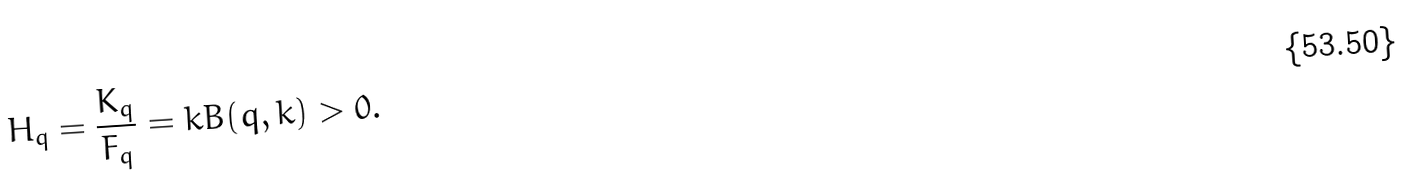Convert formula to latex. <formula><loc_0><loc_0><loc_500><loc_500>H _ { q } = \frac { K _ { q } } { F _ { q } } = k B ( q , k ) > 0 .</formula> 